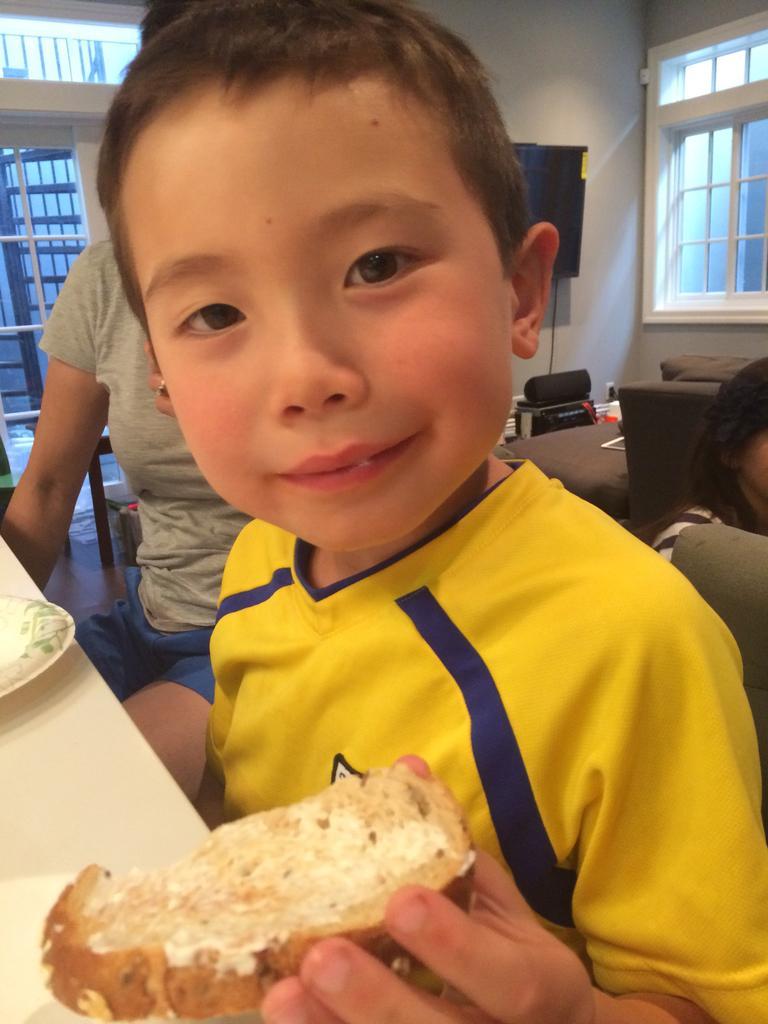Please provide a concise description of this image. In this image, we can see a kid sitting and holding a food item, there is a table, we can see two people behind the kid, we can see the wall and we can see the windows. 